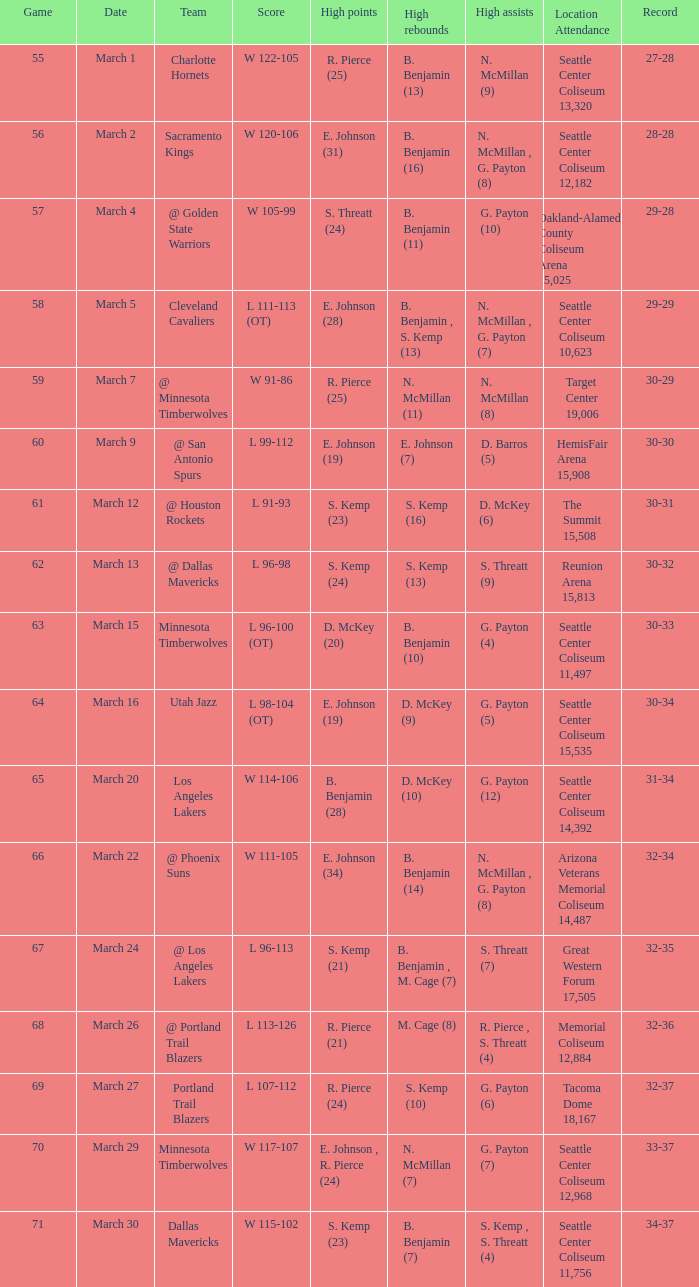Whichscore has a seattle center coliseum location attendance of 11,497? L 96-100 (OT). 